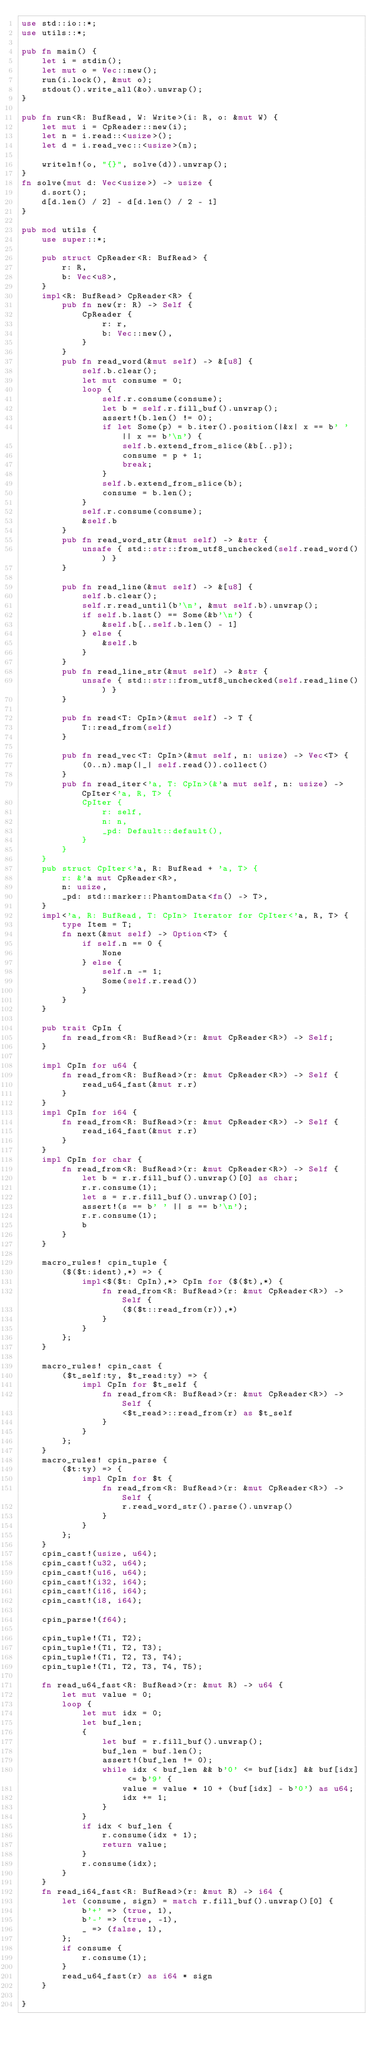<code> <loc_0><loc_0><loc_500><loc_500><_Rust_>use std::io::*;
use utils::*;

pub fn main() {
    let i = stdin();
    let mut o = Vec::new();
    run(i.lock(), &mut o);
    stdout().write_all(&o).unwrap();
}

pub fn run<R: BufRead, W: Write>(i: R, o: &mut W) {
    let mut i = CpReader::new(i);
    let n = i.read::<usize>();
    let d = i.read_vec::<usize>(n);

    writeln!(o, "{}", solve(d)).unwrap();
}
fn solve(mut d: Vec<usize>) -> usize {
    d.sort();
    d[d.len() / 2] - d[d.len() / 2 - 1]
}

pub mod utils {
    use super::*;

    pub struct CpReader<R: BufRead> {
        r: R,
        b: Vec<u8>,
    }
    impl<R: BufRead> CpReader<R> {
        pub fn new(r: R) -> Self {
            CpReader {
                r: r,
                b: Vec::new(),
            }
        }
        pub fn read_word(&mut self) -> &[u8] {
            self.b.clear();
            let mut consume = 0;
            loop {
                self.r.consume(consume);
                let b = self.r.fill_buf().unwrap();
                assert!(b.len() != 0);
                if let Some(p) = b.iter().position(|&x| x == b' ' || x == b'\n') {
                    self.b.extend_from_slice(&b[..p]);
                    consume = p + 1;
                    break;
                }
                self.b.extend_from_slice(b);
                consume = b.len();
            }
            self.r.consume(consume);
            &self.b
        }
        pub fn read_word_str(&mut self) -> &str {
            unsafe { std::str::from_utf8_unchecked(self.read_word()) }
        }

        pub fn read_line(&mut self) -> &[u8] {
            self.b.clear();
            self.r.read_until(b'\n', &mut self.b).unwrap();
            if self.b.last() == Some(&b'\n') {
                &self.b[..self.b.len() - 1]
            } else {
                &self.b
            }
        }
        pub fn read_line_str(&mut self) -> &str {
            unsafe { std::str::from_utf8_unchecked(self.read_line()) }
        }

        pub fn read<T: CpIn>(&mut self) -> T {
            T::read_from(self)
        }

        pub fn read_vec<T: CpIn>(&mut self, n: usize) -> Vec<T> {
            (0..n).map(|_| self.read()).collect()
        }
        pub fn read_iter<'a, T: CpIn>(&'a mut self, n: usize) -> CpIter<'a, R, T> {
            CpIter {
                r: self,
                n: n,
                _pd: Default::default(),
            }
        }
    }
    pub struct CpIter<'a, R: BufRead + 'a, T> {
        r: &'a mut CpReader<R>,
        n: usize,
        _pd: std::marker::PhantomData<fn() -> T>,
    }
    impl<'a, R: BufRead, T: CpIn> Iterator for CpIter<'a, R, T> {
        type Item = T;
        fn next(&mut self) -> Option<T> {
            if self.n == 0 {
                None
            } else {
                self.n -= 1;
                Some(self.r.read())
            }
        }
    }

    pub trait CpIn {
        fn read_from<R: BufRead>(r: &mut CpReader<R>) -> Self;
    }

    impl CpIn for u64 {
        fn read_from<R: BufRead>(r: &mut CpReader<R>) -> Self {
            read_u64_fast(&mut r.r)
        }
    }
    impl CpIn for i64 {
        fn read_from<R: BufRead>(r: &mut CpReader<R>) -> Self {
            read_i64_fast(&mut r.r)
        }
    }
    impl CpIn for char {
        fn read_from<R: BufRead>(r: &mut CpReader<R>) -> Self {
            let b = r.r.fill_buf().unwrap()[0] as char;
            r.r.consume(1);
            let s = r.r.fill_buf().unwrap()[0];
            assert!(s == b' ' || s == b'\n');
            r.r.consume(1);
            b
        }
    }

    macro_rules! cpin_tuple {
        ($($t:ident),*) => {
            impl<$($t: CpIn),*> CpIn for ($($t),*) {
                fn read_from<R: BufRead>(r: &mut CpReader<R>) -> Self {
                    ($($t::read_from(r)),*)
                }
            }
        };
    }

    macro_rules! cpin_cast {
        ($t_self:ty, $t_read:ty) => {
            impl CpIn for $t_self {
                fn read_from<R: BufRead>(r: &mut CpReader<R>) -> Self {
                    <$t_read>::read_from(r) as $t_self
                }
            }
        };
    }
    macro_rules! cpin_parse {
        ($t:ty) => {
            impl CpIn for $t {
                fn read_from<R: BufRead>(r: &mut CpReader<R>) -> Self {
                    r.read_word_str().parse().unwrap()
                }
            }
        };
    }
    cpin_cast!(usize, u64);
    cpin_cast!(u32, u64);
    cpin_cast!(u16, u64);
    cpin_cast!(i32, i64);
    cpin_cast!(i16, i64);
    cpin_cast!(i8, i64);

    cpin_parse!(f64);

    cpin_tuple!(T1, T2);
    cpin_tuple!(T1, T2, T3);
    cpin_tuple!(T1, T2, T3, T4);
    cpin_tuple!(T1, T2, T3, T4, T5);

    fn read_u64_fast<R: BufRead>(r: &mut R) -> u64 {
        let mut value = 0;
        loop {
            let mut idx = 0;
            let buf_len;
            {
                let buf = r.fill_buf().unwrap();
                buf_len = buf.len();
                assert!(buf_len != 0);
                while idx < buf_len && b'0' <= buf[idx] && buf[idx] <= b'9' {
                    value = value * 10 + (buf[idx] - b'0') as u64;
                    idx += 1;
                }
            }
            if idx < buf_len {
                r.consume(idx + 1);
                return value;
            }
            r.consume(idx);
        }
    }
    fn read_i64_fast<R: BufRead>(r: &mut R) -> i64 {
        let (consume, sign) = match r.fill_buf().unwrap()[0] {
            b'+' => (true, 1),
            b'-' => (true, -1),
            _ => (false, 1),
        };
        if consume {
            r.consume(1);
        }
        read_u64_fast(r) as i64 * sign
    }

}
</code> 